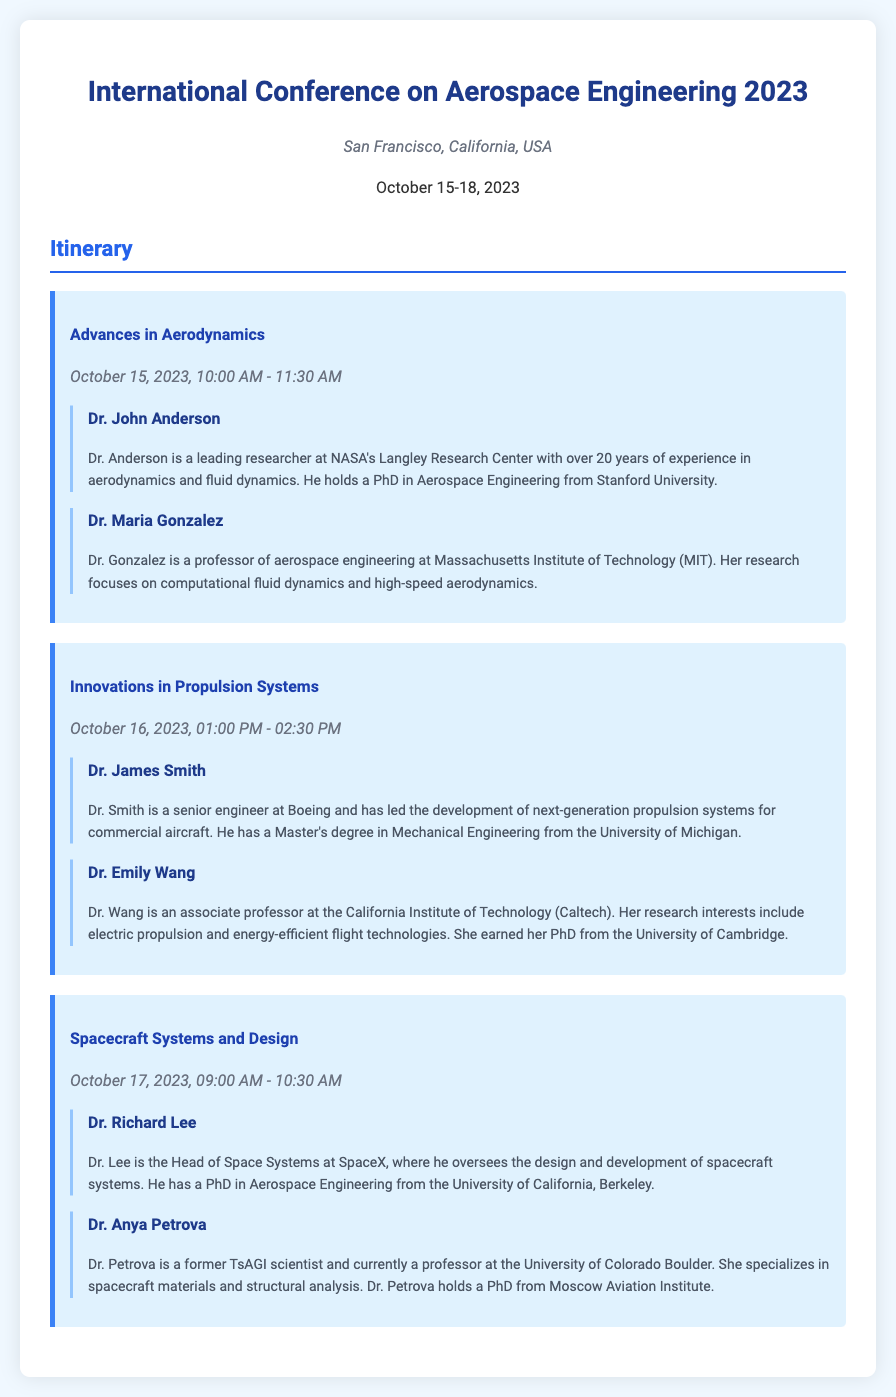What is the title of the first session? The title of the first session is found in the "session-title" section of the first session, which is "Advances in Aerodynamics."
Answer: Advances in Aerodynamics Who is the speaker for the "Innovations in Propulsion Systems" session? The speakers for the "Innovations in Propulsion Systems" session are listed under that session, showing "Dr. James Smith" and "Dr. Emily Wang."
Answer: Dr. James Smith What is the date and time for the "Spacecraft Systems and Design" session? The date and time for the "Spacecraft Systems and Design" session is mentioned directly below the session title, which indicates it is on "October 17, 2023, 09:00 AM - 10:30 AM."
Answer: October 17, 2023, 09:00 AM - 10:30 AM How many speakers are listed for the "Advances in Aerodynamics" session? The number of speakers for the "Advances in Aerodynamics" session is counted from the speaker sections under that session, which are "Dr. John Anderson" and "Dr. Maria Gonzalez."
Answer: 2 What is Dr. Petrova's area of specialization? Dr. Petrova's specialization is detailed in her speaker bio, which states she specializes in "spacecraft materials and structural analysis."
Answer: spacecraft materials and structural analysis Where is the conference taking place? The location of the conference is specified in the "header-info" section, which states it is in "San Francisco, California, USA."
Answer: San Francisco, California, USA What organization does Dr. Anderson represent? Dr. Anderson's association is noted in his bio, stating he is a researcher at "NASA's Langley Research Center."
Answer: NASA's Langley Research Center 